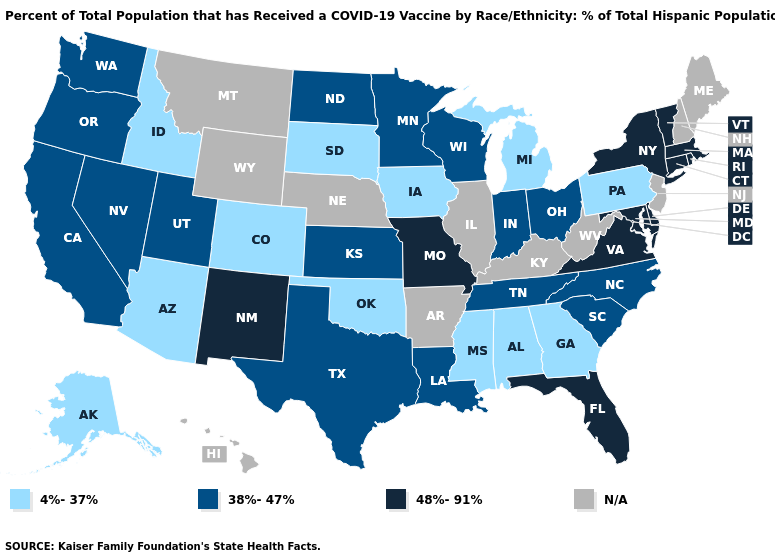Name the states that have a value in the range 48%-91%?
Be succinct. Connecticut, Delaware, Florida, Maryland, Massachusetts, Missouri, New Mexico, New York, Rhode Island, Vermont, Virginia. Name the states that have a value in the range 48%-91%?
Short answer required. Connecticut, Delaware, Florida, Maryland, Massachusetts, Missouri, New Mexico, New York, Rhode Island, Vermont, Virginia. Among the states that border Maryland , which have the lowest value?
Give a very brief answer. Pennsylvania. Among the states that border Nevada , which have the highest value?
Answer briefly. California, Oregon, Utah. What is the value of Michigan?
Be succinct. 4%-37%. What is the value of Oklahoma?
Short answer required. 4%-37%. What is the lowest value in the MidWest?
Answer briefly. 4%-37%. Does the first symbol in the legend represent the smallest category?
Answer briefly. Yes. Which states hav the highest value in the South?
Write a very short answer. Delaware, Florida, Maryland, Virginia. How many symbols are there in the legend?
Write a very short answer. 4. What is the value of Minnesota?
Give a very brief answer. 38%-47%. Name the states that have a value in the range 38%-47%?
Write a very short answer. California, Indiana, Kansas, Louisiana, Minnesota, Nevada, North Carolina, North Dakota, Ohio, Oregon, South Carolina, Tennessee, Texas, Utah, Washington, Wisconsin. Does Oregon have the highest value in the West?
Quick response, please. No. 